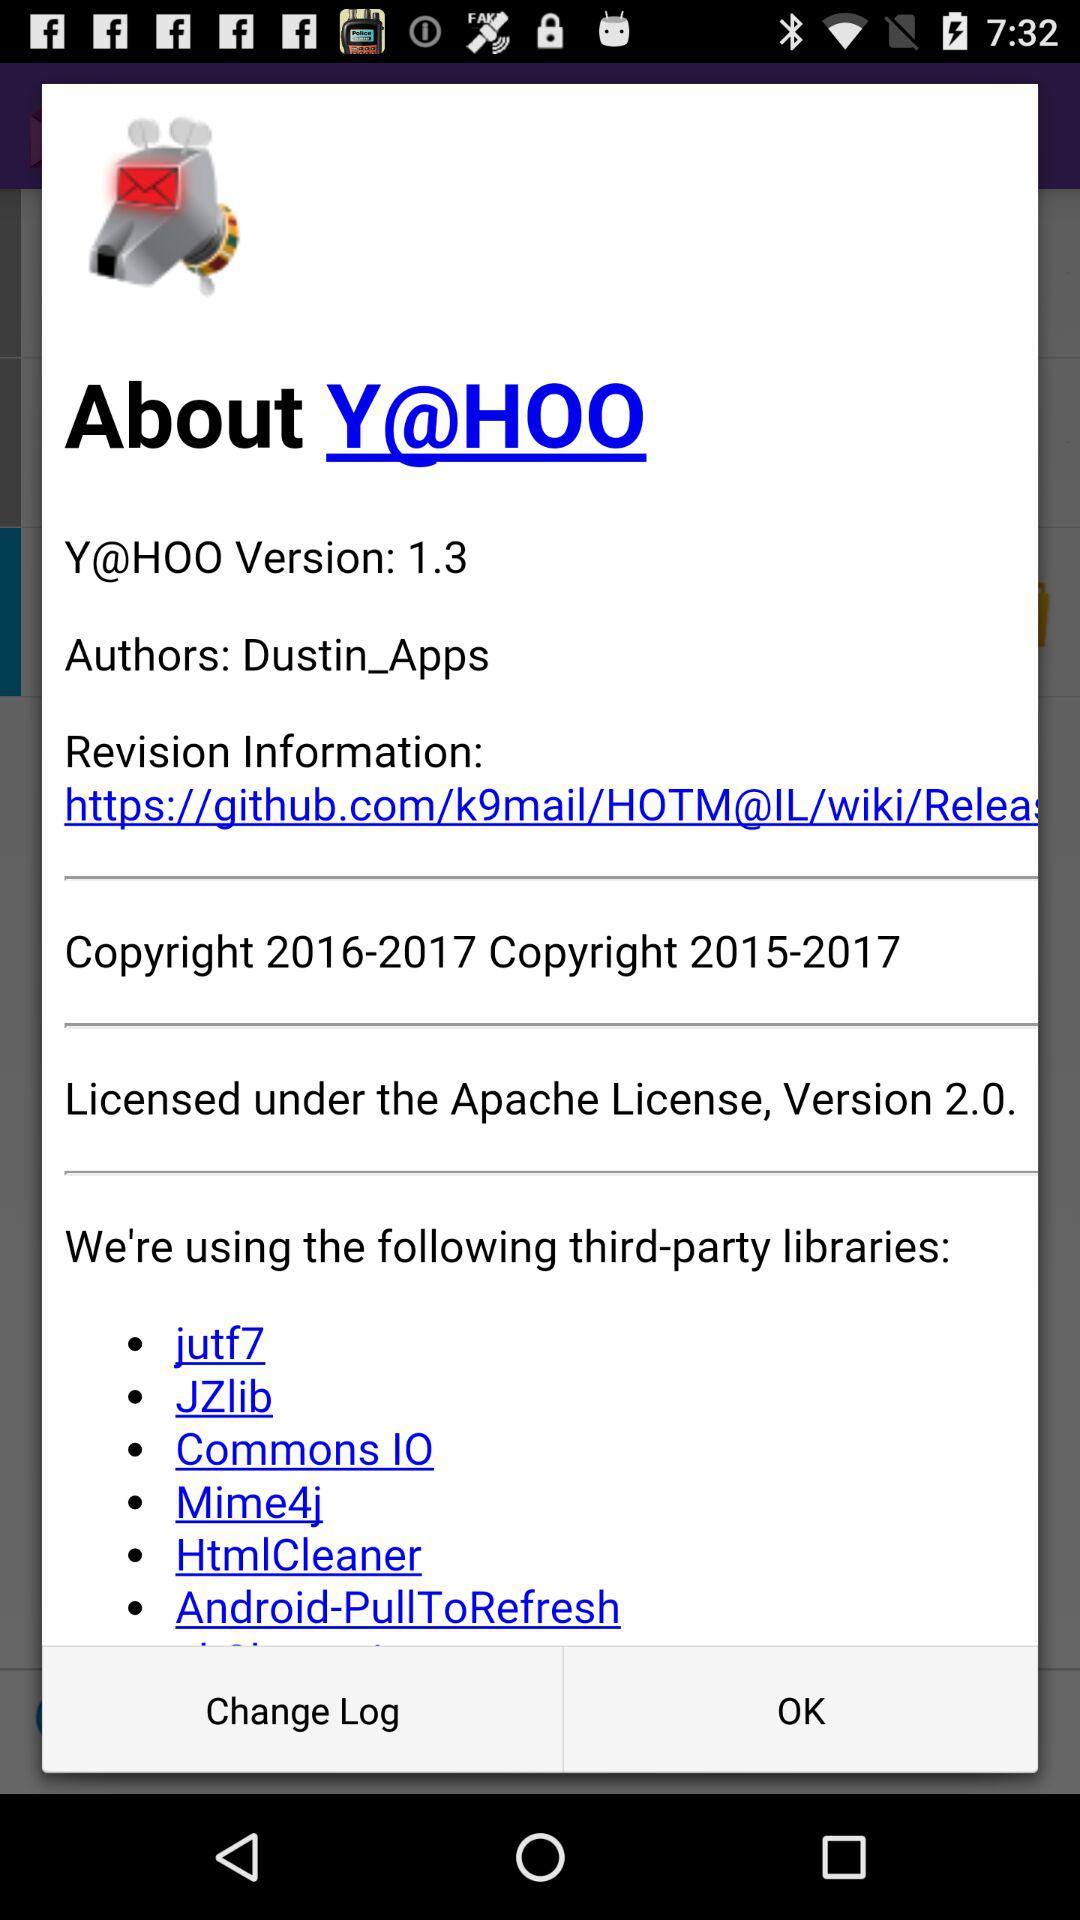How does one choose a third-party library for a project? Choosing a third-party library involves evaluating the library's functionality, compatibility with the project, community support, documentation, licensing, and its maintenance track record to ensure it's a reliable and sustainable choice for the project's needs. 